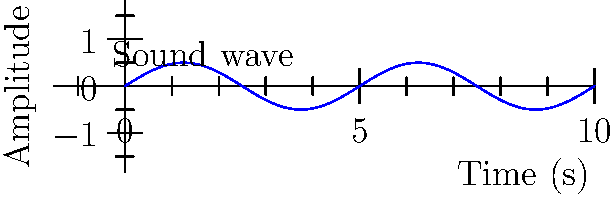As a pop culture enthusiast recommending podcasts, you're visiting a new podcast studio. The studio engineer shows you a graph of a sound wave produced during a recording session. The wave follows the function $A(t) = 0.5 \sin(\frac{2\pi t}{5})$, where $A$ is the amplitude in meters and $t$ is time in seconds. What is the wavelength of this sound wave in meters, assuming the speed of sound is 343 m/s? To find the wavelength, we'll follow these steps:

1) First, we need to find the period of the wave. The period is the time it takes for one complete cycle of the wave.

2) In the given function $A(t) = 0.5 \sin(\frac{2\pi t}{5})$, the angular frequency is $\omega = \frac{2\pi}{5}$ rad/s.

3) The period $T$ is related to the angular frequency by $T = \frac{2\pi}{\omega}$.
   So, $T = \frac{2\pi}{\frac{2\pi}{5}} = 5$ seconds.

4) Now, we can use the wave equation: $v = f\lambda$, where $v$ is the speed of the wave, $f$ is the frequency, and $\lambda$ is the wavelength.

5) We know $v = 343$ m/s (given), and $f = \frac{1}{T} = \frac{1}{5}$ Hz.

6) Substituting into the wave equation:
   $343 = \frac{1}{5}\lambda$

7) Solving for $\lambda$:
   $\lambda = 343 \cdot 5 = 1715$ meters

Therefore, the wavelength of the sound wave is 1715 meters.
Answer: 1715 m 